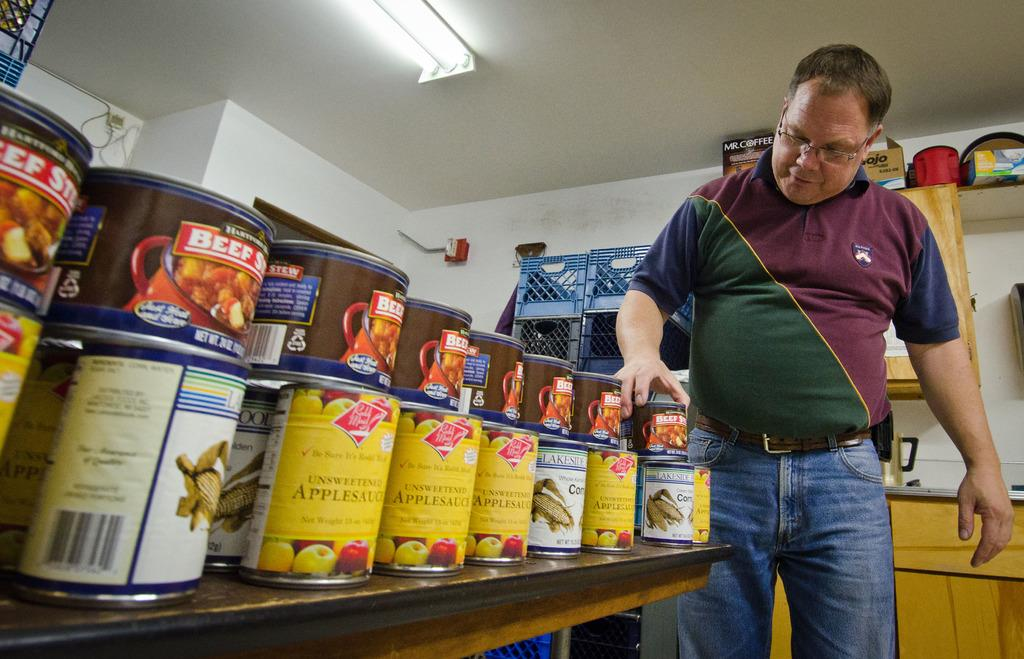Who or what is present in the image? There is a person in the image. What objects can be seen in the image besides the person? There are boxes and a fan in the image. What type of structure is visible in the image? There is a wall in the image. How many eyes does the ant have in the image? There is no ant present in the image, so it is not possible to determine the number of eyes it might have. 